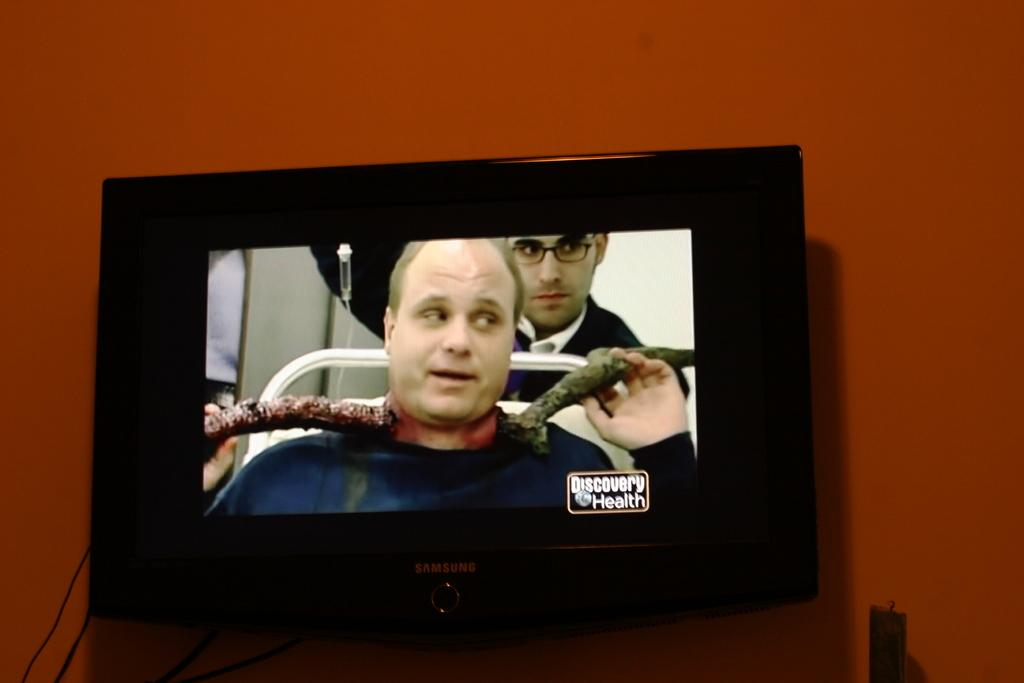What electronic device is present in the image? There is a television in the image. What can be seen on the television? Two men are visible on the television. Are there any words or phrases on the television? Yes, there is text written on the television. What can be seen in the background of the image? There is a wall in the background of the image. What type of tent is visible in the image? There is no tent present in the image. How many leaves are on the egg in the image? There is no egg or leaves present in the image. 